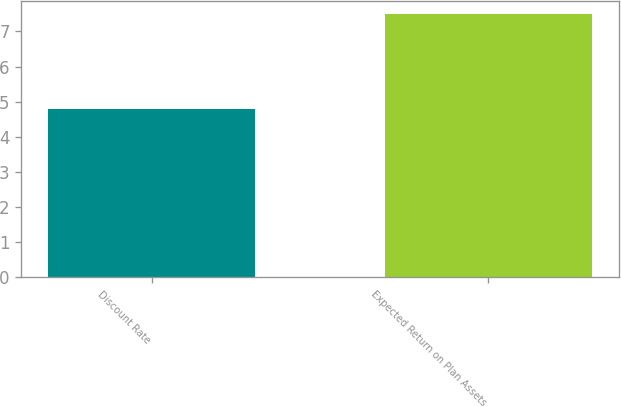<chart> <loc_0><loc_0><loc_500><loc_500><bar_chart><fcel>Discount Rate<fcel>Expected Return on Plan Assets<nl><fcel>4.8<fcel>7.5<nl></chart> 